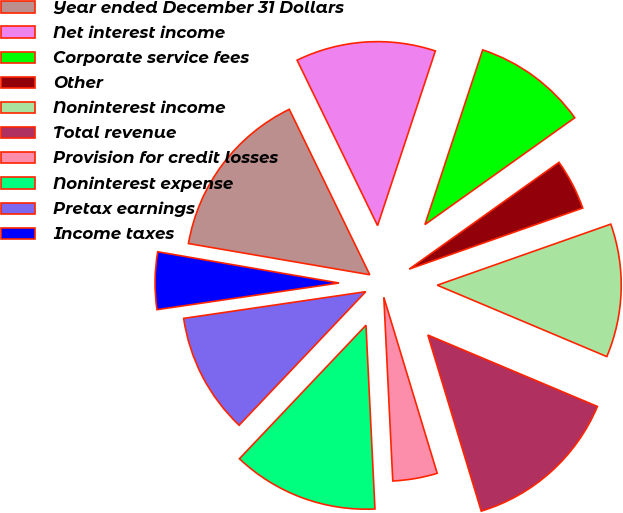Convert chart to OTSL. <chart><loc_0><loc_0><loc_500><loc_500><pie_chart><fcel>Year ended December 31 Dollars<fcel>Net interest income<fcel>Corporate service fees<fcel>Other<fcel>Noninterest income<fcel>Total revenue<fcel>Provision for credit losses<fcel>Noninterest expense<fcel>Pretax earnings<fcel>Income taxes<nl><fcel>15.08%<fcel>12.29%<fcel>10.06%<fcel>4.47%<fcel>11.73%<fcel>13.97%<fcel>3.91%<fcel>12.85%<fcel>10.61%<fcel>5.03%<nl></chart> 